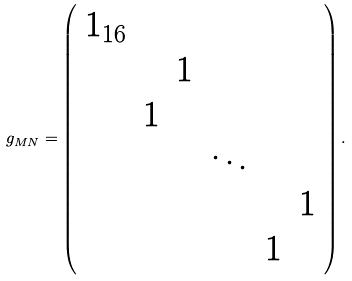<formula> <loc_0><loc_0><loc_500><loc_500>g _ { M N } = \left ( \begin{array} { c c c c c c } { 1 } _ { 1 6 } \\ & & 1 \\ & 1 \\ & & & \ddots \\ & & & & & 1 \\ & & & & 1 \end{array} \right ) .</formula> 